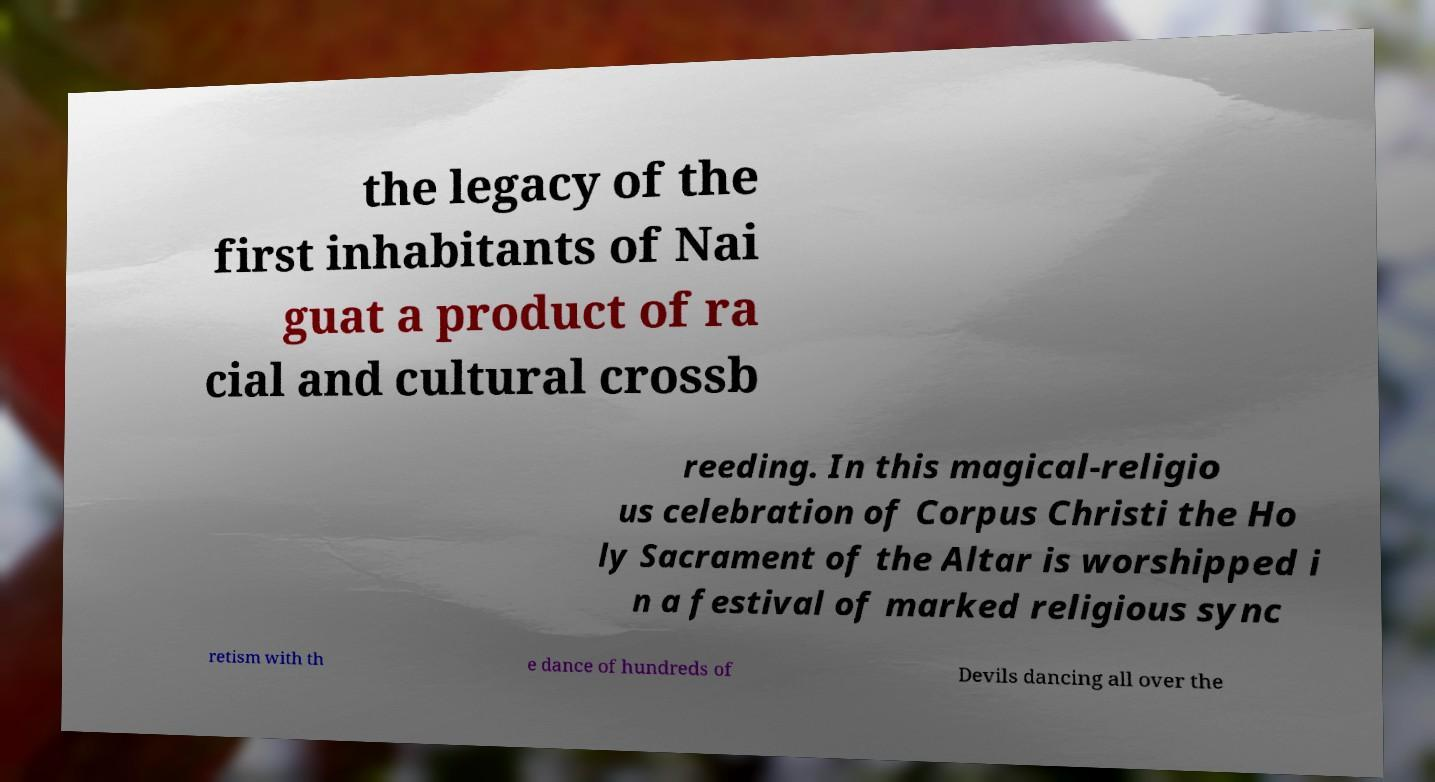Can you accurately transcribe the text from the provided image for me? the legacy of the first inhabitants of Nai guat a product of ra cial and cultural crossb reeding. In this magical-religio us celebration of Corpus Christi the Ho ly Sacrament of the Altar is worshipped i n a festival of marked religious sync retism with th e dance of hundreds of Devils dancing all over the 